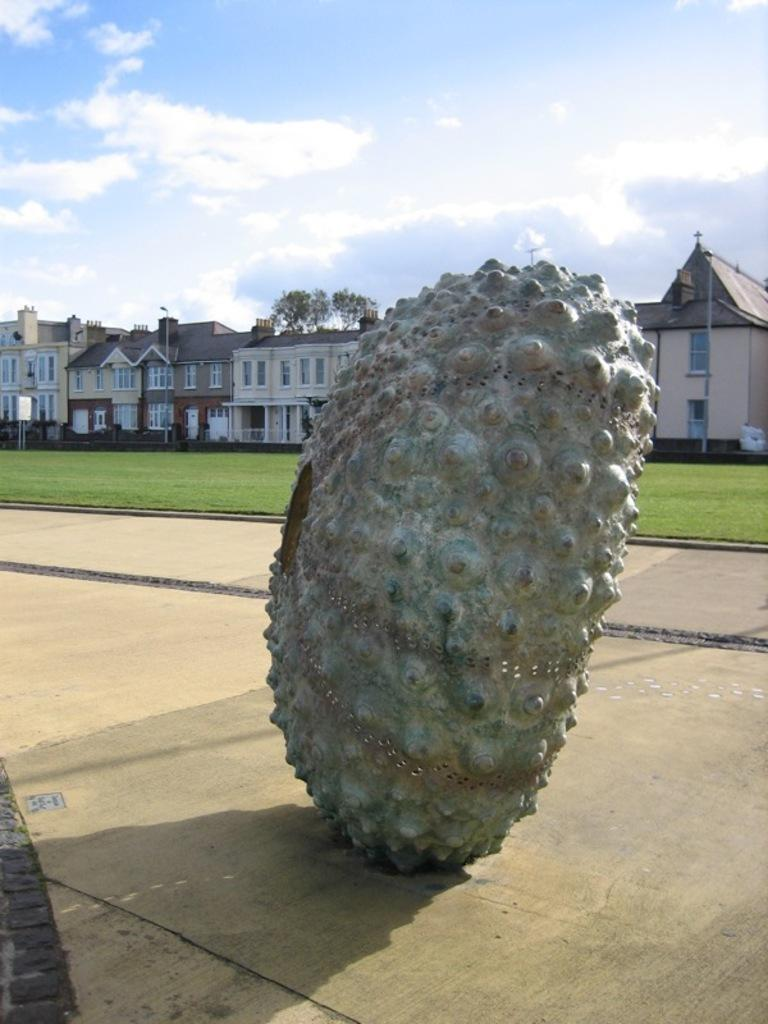What is the main subject in the center of the image? There is a headstone in the shape of a shell in the center of the image. What type of environment is visible in the background of the image? There is grassland, houses, and trees in the background of the image. What type of cracker is being used to decorate the headstone in the image? There is no cracker present in the image, and the headstone is not being decorated. 